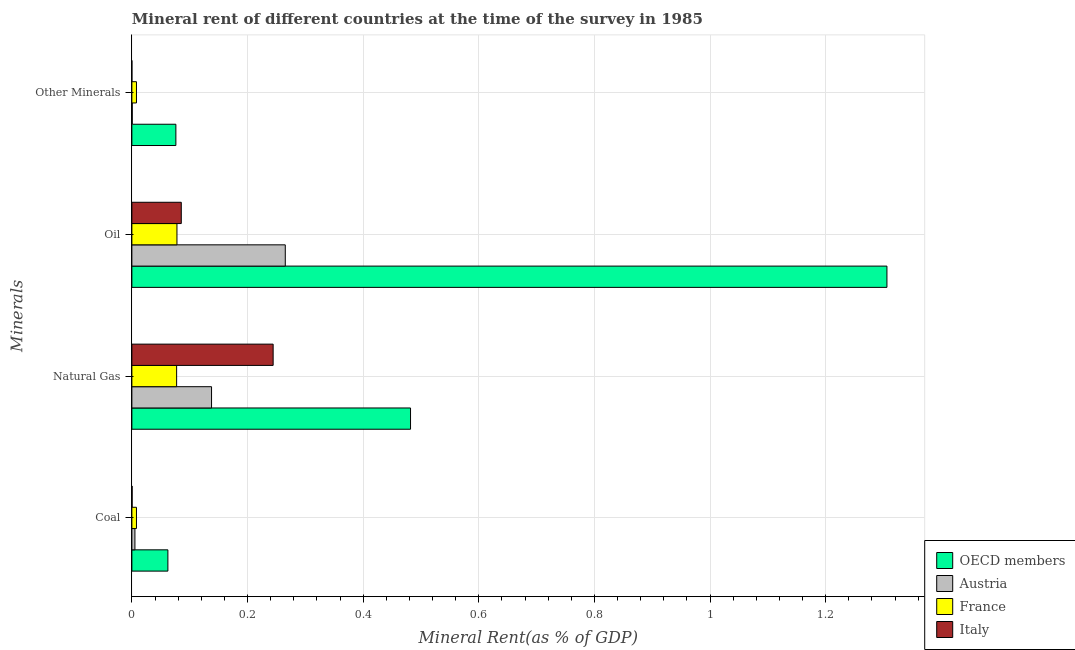How many different coloured bars are there?
Keep it short and to the point. 4. Are the number of bars per tick equal to the number of legend labels?
Ensure brevity in your answer.  Yes. What is the label of the 4th group of bars from the top?
Your answer should be very brief. Coal. What is the coal rent in France?
Your answer should be compact. 0.01. Across all countries, what is the maximum natural gas rent?
Keep it short and to the point. 0.48. Across all countries, what is the minimum natural gas rent?
Keep it short and to the point. 0.08. In which country was the natural gas rent minimum?
Offer a terse response. France. What is the total  rent of other minerals in the graph?
Ensure brevity in your answer.  0.08. What is the difference between the coal rent in OECD members and that in Austria?
Your answer should be compact. 0.06. What is the difference between the coal rent in Italy and the  rent of other minerals in France?
Ensure brevity in your answer.  -0.01. What is the average oil rent per country?
Offer a very short reply. 0.43. What is the difference between the natural gas rent and oil rent in France?
Offer a terse response. -0. In how many countries, is the  rent of other minerals greater than 1.2800000000000002 %?
Your answer should be very brief. 0. What is the ratio of the oil rent in Italy to that in Austria?
Make the answer very short. 0.32. Is the  rent of other minerals in Austria less than that in Italy?
Give a very brief answer. No. What is the difference between the highest and the second highest oil rent?
Offer a very short reply. 1.04. What is the difference between the highest and the lowest coal rent?
Make the answer very short. 0.06. Is it the case that in every country, the sum of the coal rent and oil rent is greater than the sum of  rent of other minerals and natural gas rent?
Keep it short and to the point. No. What does the 1st bar from the top in Coal represents?
Provide a short and direct response. Italy. Where does the legend appear in the graph?
Give a very brief answer. Bottom right. How many legend labels are there?
Offer a very short reply. 4. How are the legend labels stacked?
Your answer should be compact. Vertical. What is the title of the graph?
Provide a succinct answer. Mineral rent of different countries at the time of the survey in 1985. What is the label or title of the X-axis?
Give a very brief answer. Mineral Rent(as % of GDP). What is the label or title of the Y-axis?
Your response must be concise. Minerals. What is the Mineral Rent(as % of GDP) of OECD members in Coal?
Ensure brevity in your answer.  0.06. What is the Mineral Rent(as % of GDP) in Austria in Coal?
Offer a very short reply. 0.01. What is the Mineral Rent(as % of GDP) in France in Coal?
Provide a short and direct response. 0.01. What is the Mineral Rent(as % of GDP) of Italy in Coal?
Ensure brevity in your answer.  0. What is the Mineral Rent(as % of GDP) of OECD members in Natural Gas?
Your answer should be very brief. 0.48. What is the Mineral Rent(as % of GDP) of Austria in Natural Gas?
Make the answer very short. 0.14. What is the Mineral Rent(as % of GDP) in France in Natural Gas?
Give a very brief answer. 0.08. What is the Mineral Rent(as % of GDP) in Italy in Natural Gas?
Make the answer very short. 0.24. What is the Mineral Rent(as % of GDP) of OECD members in Oil?
Provide a succinct answer. 1.31. What is the Mineral Rent(as % of GDP) of Austria in Oil?
Offer a terse response. 0.27. What is the Mineral Rent(as % of GDP) in France in Oil?
Provide a succinct answer. 0.08. What is the Mineral Rent(as % of GDP) in Italy in Oil?
Your response must be concise. 0.09. What is the Mineral Rent(as % of GDP) in OECD members in Other Minerals?
Keep it short and to the point. 0.08. What is the Mineral Rent(as % of GDP) of Austria in Other Minerals?
Provide a succinct answer. 0. What is the Mineral Rent(as % of GDP) of France in Other Minerals?
Offer a very short reply. 0.01. What is the Mineral Rent(as % of GDP) of Italy in Other Minerals?
Your answer should be compact. 9.961583224840801e-6. Across all Minerals, what is the maximum Mineral Rent(as % of GDP) in OECD members?
Keep it short and to the point. 1.31. Across all Minerals, what is the maximum Mineral Rent(as % of GDP) of Austria?
Offer a terse response. 0.27. Across all Minerals, what is the maximum Mineral Rent(as % of GDP) of France?
Your response must be concise. 0.08. Across all Minerals, what is the maximum Mineral Rent(as % of GDP) of Italy?
Offer a very short reply. 0.24. Across all Minerals, what is the minimum Mineral Rent(as % of GDP) in OECD members?
Your answer should be very brief. 0.06. Across all Minerals, what is the minimum Mineral Rent(as % of GDP) in Austria?
Offer a terse response. 0. Across all Minerals, what is the minimum Mineral Rent(as % of GDP) of France?
Make the answer very short. 0.01. Across all Minerals, what is the minimum Mineral Rent(as % of GDP) in Italy?
Ensure brevity in your answer.  9.961583224840801e-6. What is the total Mineral Rent(as % of GDP) in OECD members in the graph?
Offer a very short reply. 1.93. What is the total Mineral Rent(as % of GDP) of Austria in the graph?
Provide a short and direct response. 0.41. What is the total Mineral Rent(as % of GDP) in France in the graph?
Your response must be concise. 0.17. What is the total Mineral Rent(as % of GDP) in Italy in the graph?
Give a very brief answer. 0.33. What is the difference between the Mineral Rent(as % of GDP) of OECD members in Coal and that in Natural Gas?
Keep it short and to the point. -0.42. What is the difference between the Mineral Rent(as % of GDP) of Austria in Coal and that in Natural Gas?
Provide a succinct answer. -0.13. What is the difference between the Mineral Rent(as % of GDP) in France in Coal and that in Natural Gas?
Ensure brevity in your answer.  -0.07. What is the difference between the Mineral Rent(as % of GDP) in Italy in Coal and that in Natural Gas?
Your response must be concise. -0.24. What is the difference between the Mineral Rent(as % of GDP) of OECD members in Coal and that in Oil?
Make the answer very short. -1.24. What is the difference between the Mineral Rent(as % of GDP) in Austria in Coal and that in Oil?
Provide a short and direct response. -0.26. What is the difference between the Mineral Rent(as % of GDP) in France in Coal and that in Oil?
Provide a short and direct response. -0.07. What is the difference between the Mineral Rent(as % of GDP) of Italy in Coal and that in Oil?
Ensure brevity in your answer.  -0.09. What is the difference between the Mineral Rent(as % of GDP) in OECD members in Coal and that in Other Minerals?
Provide a succinct answer. -0.01. What is the difference between the Mineral Rent(as % of GDP) in Austria in Coal and that in Other Minerals?
Your response must be concise. 0. What is the difference between the Mineral Rent(as % of GDP) of Italy in Coal and that in Other Minerals?
Your response must be concise. 0. What is the difference between the Mineral Rent(as % of GDP) of OECD members in Natural Gas and that in Oil?
Offer a terse response. -0.82. What is the difference between the Mineral Rent(as % of GDP) of Austria in Natural Gas and that in Oil?
Make the answer very short. -0.13. What is the difference between the Mineral Rent(as % of GDP) in France in Natural Gas and that in Oil?
Keep it short and to the point. -0. What is the difference between the Mineral Rent(as % of GDP) in Italy in Natural Gas and that in Oil?
Provide a short and direct response. 0.16. What is the difference between the Mineral Rent(as % of GDP) of OECD members in Natural Gas and that in Other Minerals?
Ensure brevity in your answer.  0.41. What is the difference between the Mineral Rent(as % of GDP) in Austria in Natural Gas and that in Other Minerals?
Ensure brevity in your answer.  0.14. What is the difference between the Mineral Rent(as % of GDP) of France in Natural Gas and that in Other Minerals?
Ensure brevity in your answer.  0.07. What is the difference between the Mineral Rent(as % of GDP) of Italy in Natural Gas and that in Other Minerals?
Give a very brief answer. 0.24. What is the difference between the Mineral Rent(as % of GDP) of OECD members in Oil and that in Other Minerals?
Give a very brief answer. 1.23. What is the difference between the Mineral Rent(as % of GDP) of Austria in Oil and that in Other Minerals?
Your answer should be compact. 0.26. What is the difference between the Mineral Rent(as % of GDP) in France in Oil and that in Other Minerals?
Your response must be concise. 0.07. What is the difference between the Mineral Rent(as % of GDP) in Italy in Oil and that in Other Minerals?
Give a very brief answer. 0.09. What is the difference between the Mineral Rent(as % of GDP) in OECD members in Coal and the Mineral Rent(as % of GDP) in Austria in Natural Gas?
Give a very brief answer. -0.08. What is the difference between the Mineral Rent(as % of GDP) of OECD members in Coal and the Mineral Rent(as % of GDP) of France in Natural Gas?
Your answer should be very brief. -0.02. What is the difference between the Mineral Rent(as % of GDP) of OECD members in Coal and the Mineral Rent(as % of GDP) of Italy in Natural Gas?
Offer a terse response. -0.18. What is the difference between the Mineral Rent(as % of GDP) in Austria in Coal and the Mineral Rent(as % of GDP) in France in Natural Gas?
Offer a very short reply. -0.07. What is the difference between the Mineral Rent(as % of GDP) in Austria in Coal and the Mineral Rent(as % of GDP) in Italy in Natural Gas?
Your response must be concise. -0.24. What is the difference between the Mineral Rent(as % of GDP) in France in Coal and the Mineral Rent(as % of GDP) in Italy in Natural Gas?
Ensure brevity in your answer.  -0.24. What is the difference between the Mineral Rent(as % of GDP) in OECD members in Coal and the Mineral Rent(as % of GDP) in Austria in Oil?
Your response must be concise. -0.2. What is the difference between the Mineral Rent(as % of GDP) in OECD members in Coal and the Mineral Rent(as % of GDP) in France in Oil?
Keep it short and to the point. -0.02. What is the difference between the Mineral Rent(as % of GDP) in OECD members in Coal and the Mineral Rent(as % of GDP) in Italy in Oil?
Offer a very short reply. -0.02. What is the difference between the Mineral Rent(as % of GDP) of Austria in Coal and the Mineral Rent(as % of GDP) of France in Oil?
Provide a succinct answer. -0.07. What is the difference between the Mineral Rent(as % of GDP) in Austria in Coal and the Mineral Rent(as % of GDP) in Italy in Oil?
Your answer should be compact. -0.08. What is the difference between the Mineral Rent(as % of GDP) in France in Coal and the Mineral Rent(as % of GDP) in Italy in Oil?
Make the answer very short. -0.08. What is the difference between the Mineral Rent(as % of GDP) in OECD members in Coal and the Mineral Rent(as % of GDP) in Austria in Other Minerals?
Provide a succinct answer. 0.06. What is the difference between the Mineral Rent(as % of GDP) in OECD members in Coal and the Mineral Rent(as % of GDP) in France in Other Minerals?
Make the answer very short. 0.05. What is the difference between the Mineral Rent(as % of GDP) in OECD members in Coal and the Mineral Rent(as % of GDP) in Italy in Other Minerals?
Your response must be concise. 0.06. What is the difference between the Mineral Rent(as % of GDP) in Austria in Coal and the Mineral Rent(as % of GDP) in France in Other Minerals?
Ensure brevity in your answer.  -0. What is the difference between the Mineral Rent(as % of GDP) of Austria in Coal and the Mineral Rent(as % of GDP) of Italy in Other Minerals?
Make the answer very short. 0.01. What is the difference between the Mineral Rent(as % of GDP) of France in Coal and the Mineral Rent(as % of GDP) of Italy in Other Minerals?
Keep it short and to the point. 0.01. What is the difference between the Mineral Rent(as % of GDP) in OECD members in Natural Gas and the Mineral Rent(as % of GDP) in Austria in Oil?
Give a very brief answer. 0.22. What is the difference between the Mineral Rent(as % of GDP) of OECD members in Natural Gas and the Mineral Rent(as % of GDP) of France in Oil?
Your answer should be compact. 0.4. What is the difference between the Mineral Rent(as % of GDP) of OECD members in Natural Gas and the Mineral Rent(as % of GDP) of Italy in Oil?
Your answer should be compact. 0.4. What is the difference between the Mineral Rent(as % of GDP) of Austria in Natural Gas and the Mineral Rent(as % of GDP) of France in Oil?
Provide a short and direct response. 0.06. What is the difference between the Mineral Rent(as % of GDP) in Austria in Natural Gas and the Mineral Rent(as % of GDP) in Italy in Oil?
Your answer should be very brief. 0.05. What is the difference between the Mineral Rent(as % of GDP) of France in Natural Gas and the Mineral Rent(as % of GDP) of Italy in Oil?
Offer a terse response. -0.01. What is the difference between the Mineral Rent(as % of GDP) of OECD members in Natural Gas and the Mineral Rent(as % of GDP) of Austria in Other Minerals?
Your response must be concise. 0.48. What is the difference between the Mineral Rent(as % of GDP) in OECD members in Natural Gas and the Mineral Rent(as % of GDP) in France in Other Minerals?
Keep it short and to the point. 0.47. What is the difference between the Mineral Rent(as % of GDP) of OECD members in Natural Gas and the Mineral Rent(as % of GDP) of Italy in Other Minerals?
Offer a very short reply. 0.48. What is the difference between the Mineral Rent(as % of GDP) in Austria in Natural Gas and the Mineral Rent(as % of GDP) in France in Other Minerals?
Provide a short and direct response. 0.13. What is the difference between the Mineral Rent(as % of GDP) in Austria in Natural Gas and the Mineral Rent(as % of GDP) in Italy in Other Minerals?
Offer a very short reply. 0.14. What is the difference between the Mineral Rent(as % of GDP) of France in Natural Gas and the Mineral Rent(as % of GDP) of Italy in Other Minerals?
Your answer should be very brief. 0.08. What is the difference between the Mineral Rent(as % of GDP) in OECD members in Oil and the Mineral Rent(as % of GDP) in Austria in Other Minerals?
Provide a succinct answer. 1.31. What is the difference between the Mineral Rent(as % of GDP) of OECD members in Oil and the Mineral Rent(as % of GDP) of France in Other Minerals?
Keep it short and to the point. 1.3. What is the difference between the Mineral Rent(as % of GDP) of OECD members in Oil and the Mineral Rent(as % of GDP) of Italy in Other Minerals?
Your response must be concise. 1.31. What is the difference between the Mineral Rent(as % of GDP) of Austria in Oil and the Mineral Rent(as % of GDP) of France in Other Minerals?
Provide a short and direct response. 0.26. What is the difference between the Mineral Rent(as % of GDP) in Austria in Oil and the Mineral Rent(as % of GDP) in Italy in Other Minerals?
Your response must be concise. 0.27. What is the difference between the Mineral Rent(as % of GDP) in France in Oil and the Mineral Rent(as % of GDP) in Italy in Other Minerals?
Your answer should be compact. 0.08. What is the average Mineral Rent(as % of GDP) of OECD members per Minerals?
Offer a terse response. 0.48. What is the average Mineral Rent(as % of GDP) of Austria per Minerals?
Provide a succinct answer. 0.1. What is the average Mineral Rent(as % of GDP) of France per Minerals?
Offer a terse response. 0.04. What is the average Mineral Rent(as % of GDP) in Italy per Minerals?
Provide a short and direct response. 0.08. What is the difference between the Mineral Rent(as % of GDP) of OECD members and Mineral Rent(as % of GDP) of Austria in Coal?
Your response must be concise. 0.06. What is the difference between the Mineral Rent(as % of GDP) of OECD members and Mineral Rent(as % of GDP) of France in Coal?
Make the answer very short. 0.05. What is the difference between the Mineral Rent(as % of GDP) in OECD members and Mineral Rent(as % of GDP) in Italy in Coal?
Offer a very short reply. 0.06. What is the difference between the Mineral Rent(as % of GDP) in Austria and Mineral Rent(as % of GDP) in France in Coal?
Ensure brevity in your answer.  -0. What is the difference between the Mineral Rent(as % of GDP) of Austria and Mineral Rent(as % of GDP) of Italy in Coal?
Offer a very short reply. 0. What is the difference between the Mineral Rent(as % of GDP) in France and Mineral Rent(as % of GDP) in Italy in Coal?
Keep it short and to the point. 0.01. What is the difference between the Mineral Rent(as % of GDP) of OECD members and Mineral Rent(as % of GDP) of Austria in Natural Gas?
Your answer should be compact. 0.34. What is the difference between the Mineral Rent(as % of GDP) in OECD members and Mineral Rent(as % of GDP) in France in Natural Gas?
Offer a terse response. 0.4. What is the difference between the Mineral Rent(as % of GDP) of OECD members and Mineral Rent(as % of GDP) of Italy in Natural Gas?
Keep it short and to the point. 0.24. What is the difference between the Mineral Rent(as % of GDP) of Austria and Mineral Rent(as % of GDP) of France in Natural Gas?
Make the answer very short. 0.06. What is the difference between the Mineral Rent(as % of GDP) in Austria and Mineral Rent(as % of GDP) in Italy in Natural Gas?
Make the answer very short. -0.11. What is the difference between the Mineral Rent(as % of GDP) in France and Mineral Rent(as % of GDP) in Italy in Natural Gas?
Provide a short and direct response. -0.17. What is the difference between the Mineral Rent(as % of GDP) in OECD members and Mineral Rent(as % of GDP) in Austria in Oil?
Make the answer very short. 1.04. What is the difference between the Mineral Rent(as % of GDP) of OECD members and Mineral Rent(as % of GDP) of France in Oil?
Offer a very short reply. 1.23. What is the difference between the Mineral Rent(as % of GDP) in OECD members and Mineral Rent(as % of GDP) in Italy in Oil?
Your response must be concise. 1.22. What is the difference between the Mineral Rent(as % of GDP) of Austria and Mineral Rent(as % of GDP) of France in Oil?
Make the answer very short. 0.19. What is the difference between the Mineral Rent(as % of GDP) of Austria and Mineral Rent(as % of GDP) of Italy in Oil?
Your response must be concise. 0.18. What is the difference between the Mineral Rent(as % of GDP) in France and Mineral Rent(as % of GDP) in Italy in Oil?
Keep it short and to the point. -0.01. What is the difference between the Mineral Rent(as % of GDP) of OECD members and Mineral Rent(as % of GDP) of Austria in Other Minerals?
Provide a succinct answer. 0.08. What is the difference between the Mineral Rent(as % of GDP) in OECD members and Mineral Rent(as % of GDP) in France in Other Minerals?
Offer a terse response. 0.07. What is the difference between the Mineral Rent(as % of GDP) in OECD members and Mineral Rent(as % of GDP) in Italy in Other Minerals?
Give a very brief answer. 0.08. What is the difference between the Mineral Rent(as % of GDP) of Austria and Mineral Rent(as % of GDP) of France in Other Minerals?
Your answer should be compact. -0.01. What is the difference between the Mineral Rent(as % of GDP) of Austria and Mineral Rent(as % of GDP) of Italy in Other Minerals?
Give a very brief answer. 0. What is the difference between the Mineral Rent(as % of GDP) of France and Mineral Rent(as % of GDP) of Italy in Other Minerals?
Offer a terse response. 0.01. What is the ratio of the Mineral Rent(as % of GDP) of OECD members in Coal to that in Natural Gas?
Offer a terse response. 0.13. What is the ratio of the Mineral Rent(as % of GDP) in Austria in Coal to that in Natural Gas?
Your answer should be very brief. 0.04. What is the ratio of the Mineral Rent(as % of GDP) in France in Coal to that in Natural Gas?
Provide a succinct answer. 0.1. What is the ratio of the Mineral Rent(as % of GDP) in Italy in Coal to that in Natural Gas?
Keep it short and to the point. 0. What is the ratio of the Mineral Rent(as % of GDP) in OECD members in Coal to that in Oil?
Give a very brief answer. 0.05. What is the ratio of the Mineral Rent(as % of GDP) of Austria in Coal to that in Oil?
Offer a very short reply. 0.02. What is the ratio of the Mineral Rent(as % of GDP) in France in Coal to that in Oil?
Offer a terse response. 0.1. What is the ratio of the Mineral Rent(as % of GDP) in Italy in Coal to that in Oil?
Provide a succinct answer. 0. What is the ratio of the Mineral Rent(as % of GDP) in OECD members in Coal to that in Other Minerals?
Ensure brevity in your answer.  0.82. What is the ratio of the Mineral Rent(as % of GDP) of Austria in Coal to that in Other Minerals?
Provide a short and direct response. 7.99. What is the ratio of the Mineral Rent(as % of GDP) in France in Coal to that in Other Minerals?
Your answer should be compact. 1. What is the ratio of the Mineral Rent(as % of GDP) in Italy in Coal to that in Other Minerals?
Ensure brevity in your answer.  42.42. What is the ratio of the Mineral Rent(as % of GDP) of OECD members in Natural Gas to that in Oil?
Keep it short and to the point. 0.37. What is the ratio of the Mineral Rent(as % of GDP) in Austria in Natural Gas to that in Oil?
Keep it short and to the point. 0.52. What is the ratio of the Mineral Rent(as % of GDP) of France in Natural Gas to that in Oil?
Ensure brevity in your answer.  0.99. What is the ratio of the Mineral Rent(as % of GDP) of Italy in Natural Gas to that in Oil?
Provide a succinct answer. 2.86. What is the ratio of the Mineral Rent(as % of GDP) of OECD members in Natural Gas to that in Other Minerals?
Your response must be concise. 6.33. What is the ratio of the Mineral Rent(as % of GDP) in Austria in Natural Gas to that in Other Minerals?
Give a very brief answer. 209.45. What is the ratio of the Mineral Rent(as % of GDP) of France in Natural Gas to that in Other Minerals?
Your response must be concise. 9.73. What is the ratio of the Mineral Rent(as % of GDP) in Italy in Natural Gas to that in Other Minerals?
Offer a very short reply. 2.45e+04. What is the ratio of the Mineral Rent(as % of GDP) in OECD members in Oil to that in Other Minerals?
Provide a succinct answer. 17.16. What is the ratio of the Mineral Rent(as % of GDP) in Austria in Oil to that in Other Minerals?
Your answer should be compact. 403.26. What is the ratio of the Mineral Rent(as % of GDP) of France in Oil to that in Other Minerals?
Offer a very short reply. 9.8. What is the ratio of the Mineral Rent(as % of GDP) of Italy in Oil to that in Other Minerals?
Your answer should be compact. 8579.54. What is the difference between the highest and the second highest Mineral Rent(as % of GDP) of OECD members?
Your answer should be compact. 0.82. What is the difference between the highest and the second highest Mineral Rent(as % of GDP) in Austria?
Keep it short and to the point. 0.13. What is the difference between the highest and the second highest Mineral Rent(as % of GDP) of France?
Ensure brevity in your answer.  0. What is the difference between the highest and the second highest Mineral Rent(as % of GDP) in Italy?
Your answer should be very brief. 0.16. What is the difference between the highest and the lowest Mineral Rent(as % of GDP) in OECD members?
Your answer should be very brief. 1.24. What is the difference between the highest and the lowest Mineral Rent(as % of GDP) of Austria?
Make the answer very short. 0.26. What is the difference between the highest and the lowest Mineral Rent(as % of GDP) of France?
Your answer should be very brief. 0.07. What is the difference between the highest and the lowest Mineral Rent(as % of GDP) of Italy?
Offer a very short reply. 0.24. 